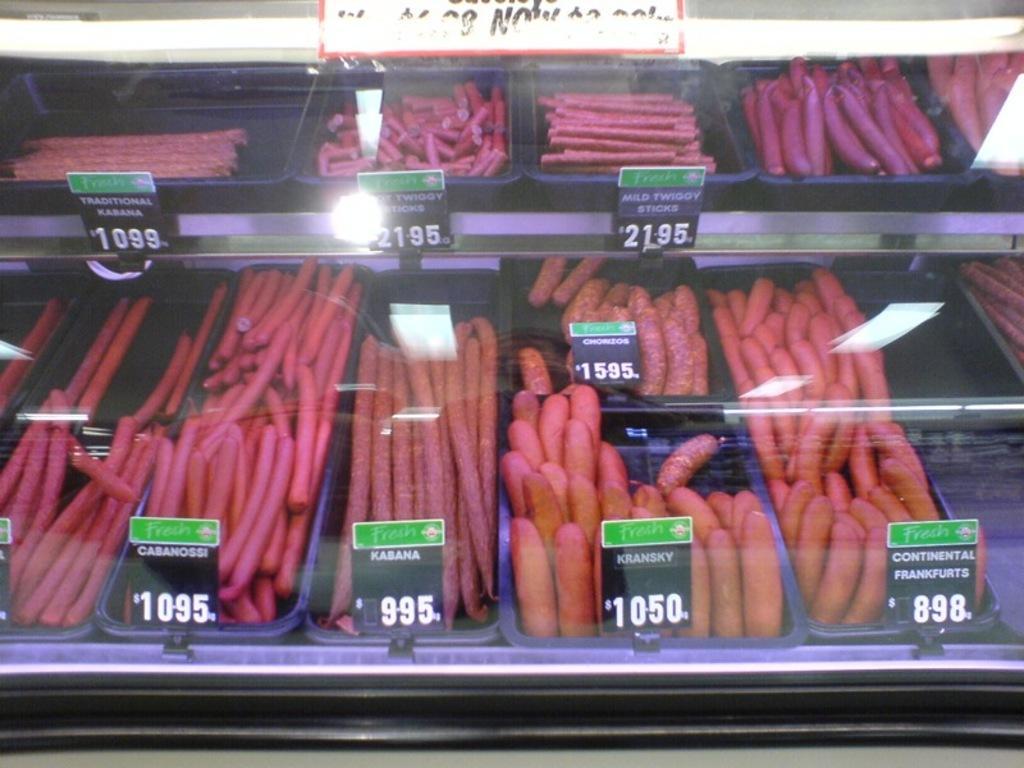Can you describe this image briefly? In this image ,I can see a food place one after the other hand there are tags for each food. 